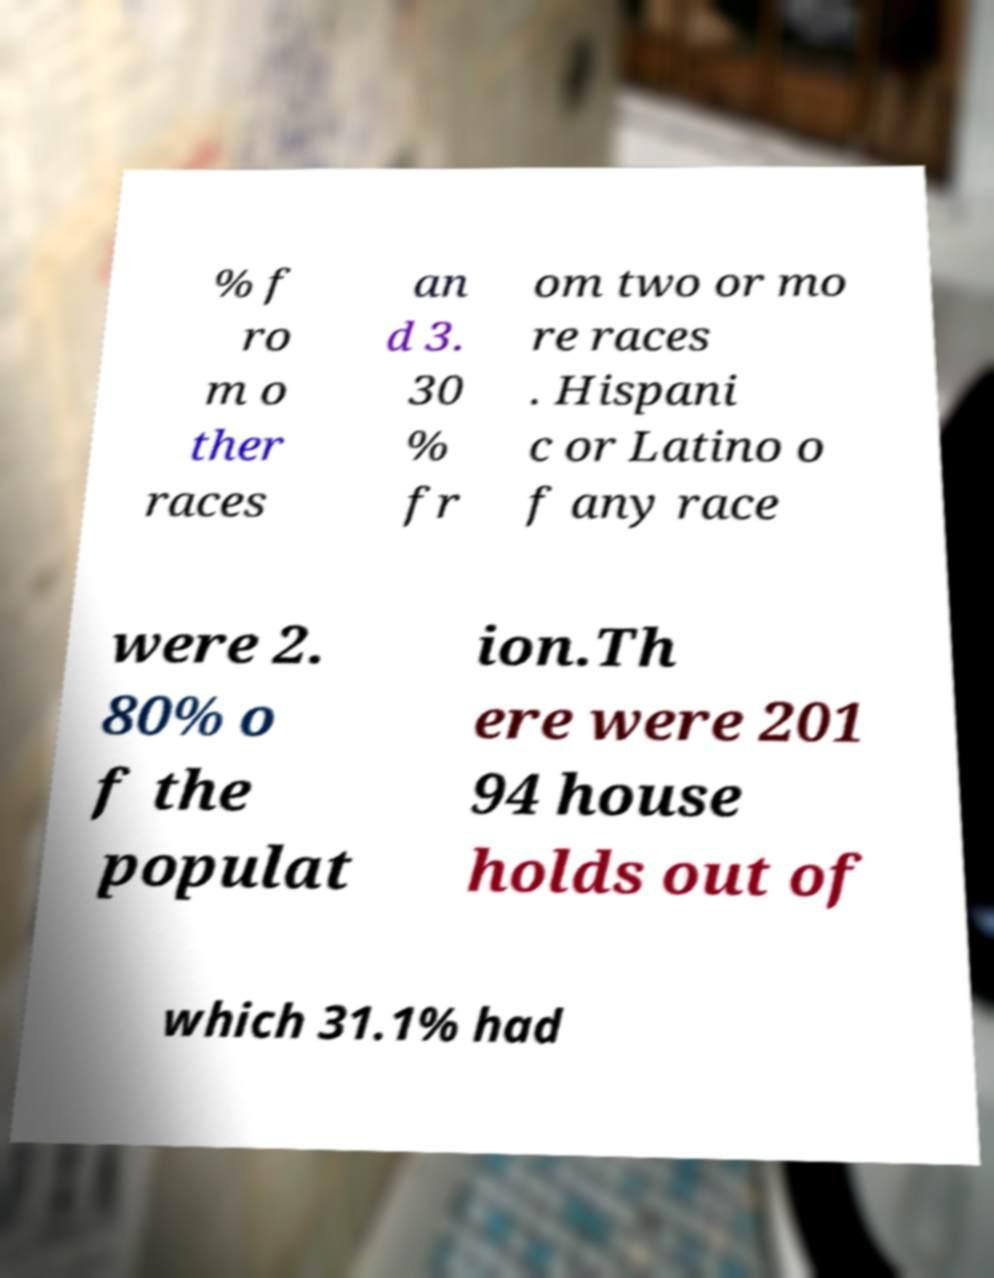Can you read and provide the text displayed in the image?This photo seems to have some interesting text. Can you extract and type it out for me? % f ro m o ther races an d 3. 30 % fr om two or mo re races . Hispani c or Latino o f any race were 2. 80% o f the populat ion.Th ere were 201 94 house holds out of which 31.1% had 